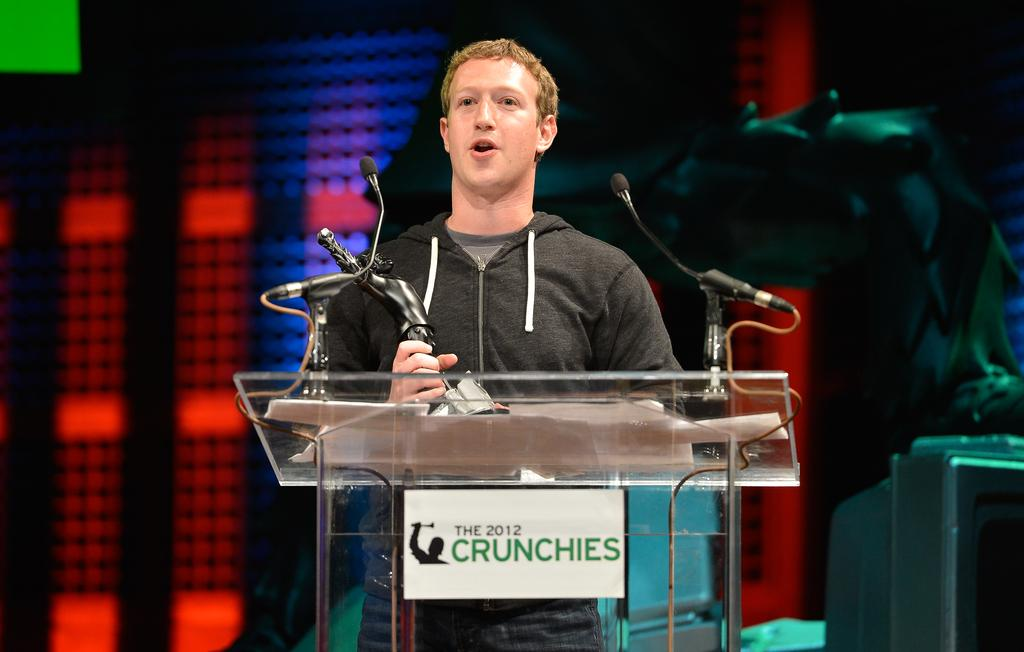What is the person in the image holding? The person is holding an award in the image. Where is the person standing in the image? The person is standing in front of a stand in the image. What can be seen on the stand in the image? The stand has microphones on it. What type of duck is visible in the image? There is no duck present in the image. What scientific discovery is being discussed in the image? The image does not depict a scientific discovery or discussion. 